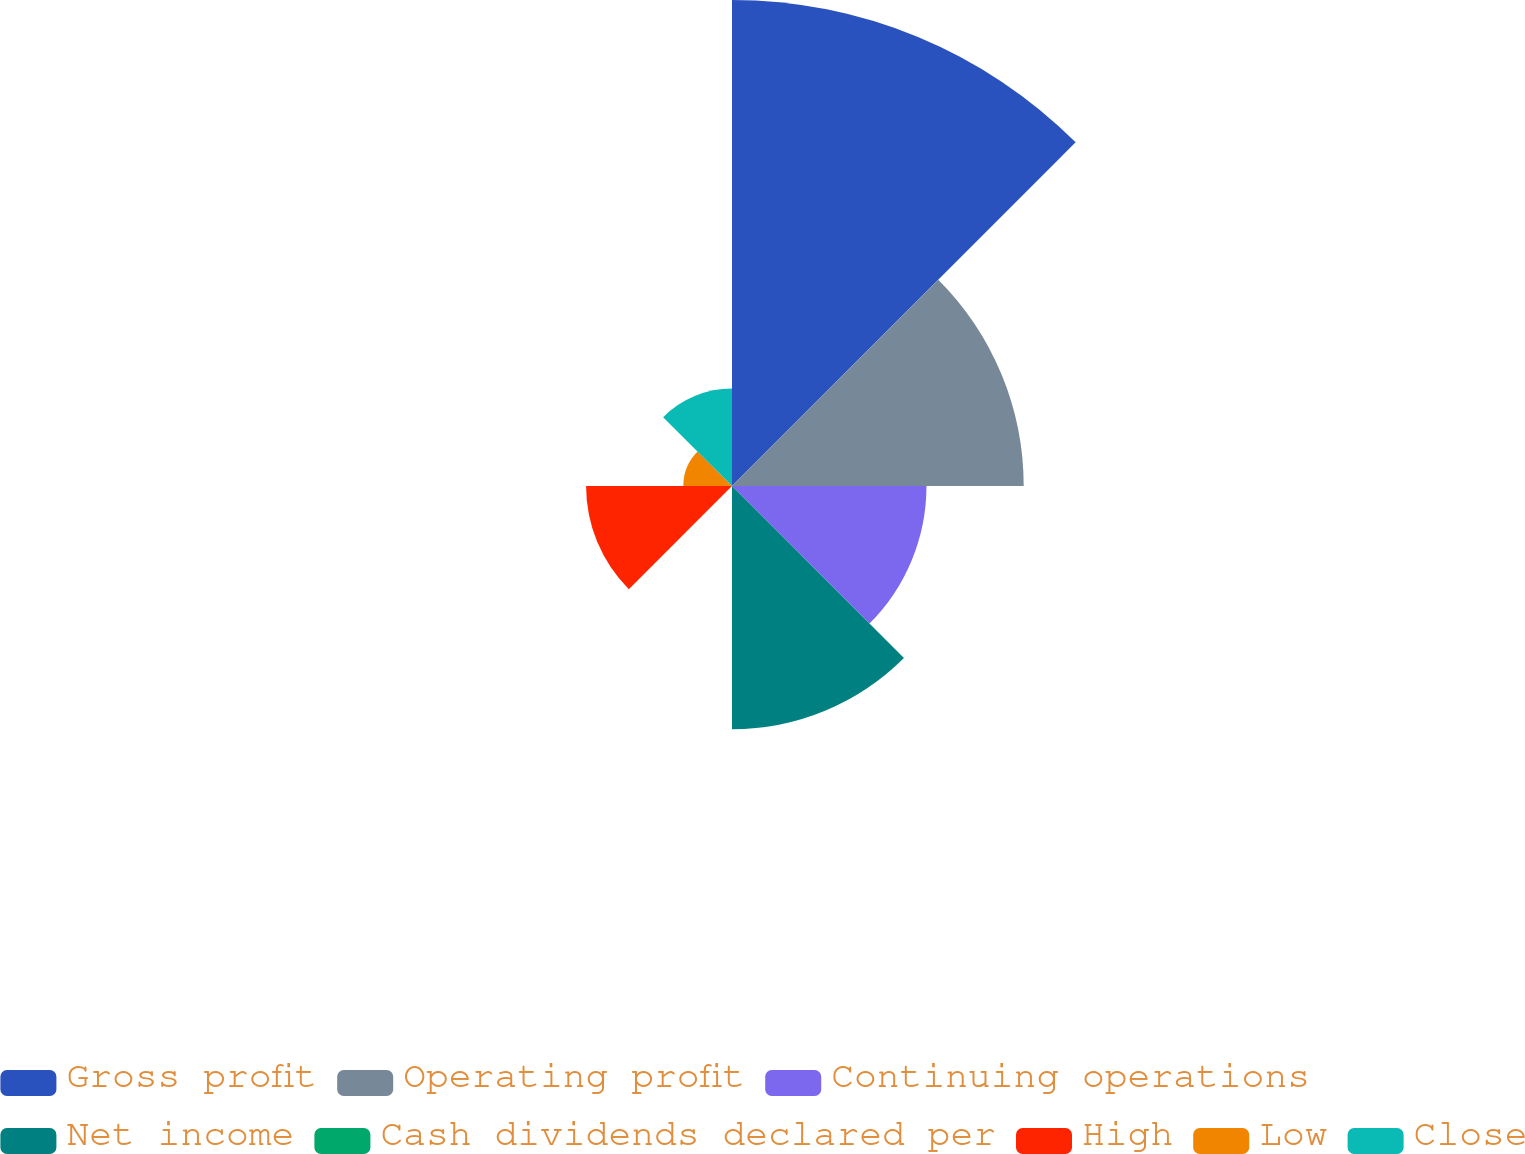Convert chart. <chart><loc_0><loc_0><loc_500><loc_500><pie_chart><fcel>Gross profit<fcel>Operating profit<fcel>Continuing operations<fcel>Net income<fcel>Cash dividends declared per<fcel>High<fcel>Low<fcel>Close<nl><fcel>32.24%<fcel>19.35%<fcel>12.9%<fcel>16.13%<fcel>0.01%<fcel>9.68%<fcel>3.23%<fcel>6.46%<nl></chart> 